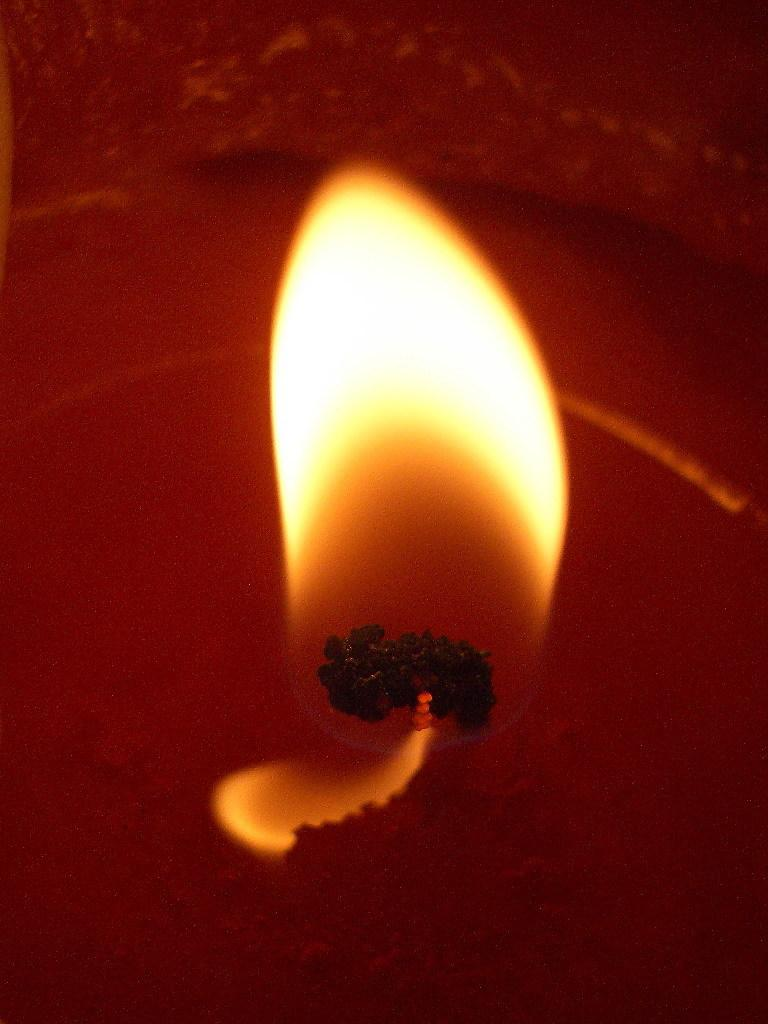What is the source of light in the image? There is a flame in the image. What object is the flame coming from? There is a candle in the image. How many friends are on the voyage in the image? There is no reference to a voyage or friends in the image; it only features a flame and a candle. 